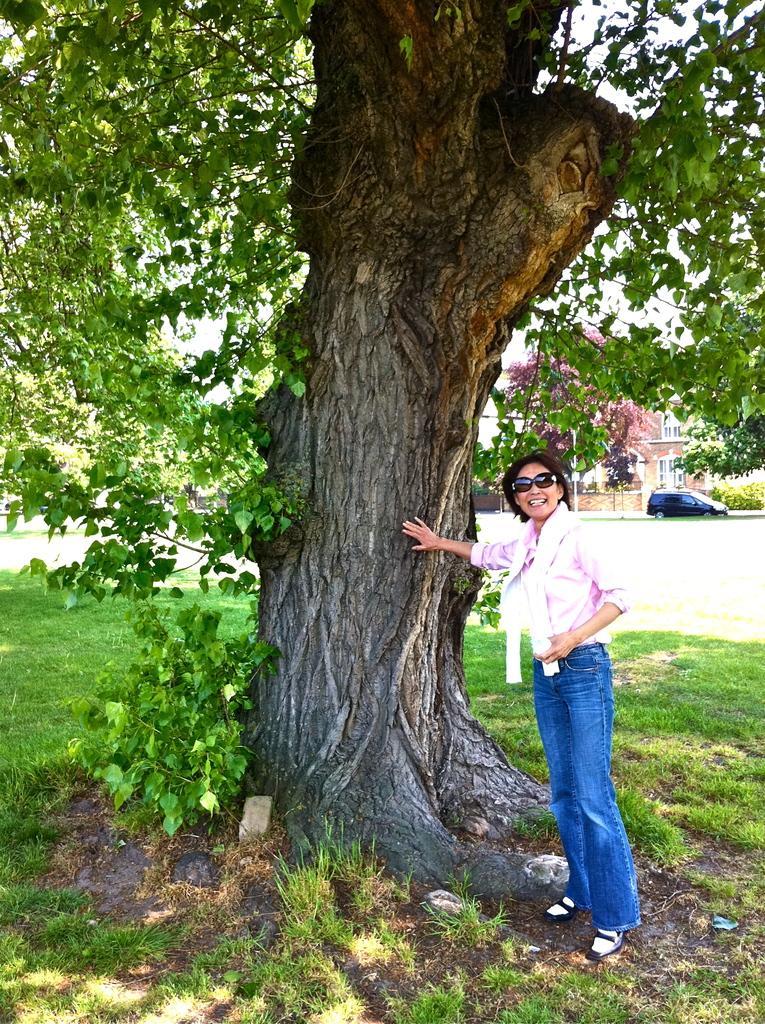In one or two sentences, can you explain what this image depicts? In this picture there is a woman who is wearing google, shirt, jeans and shoes. She is standing near to the tree. In the background I can see the car which is parked in front of the building. Beside I can see the plants and road. On the left I can see the green grass. 